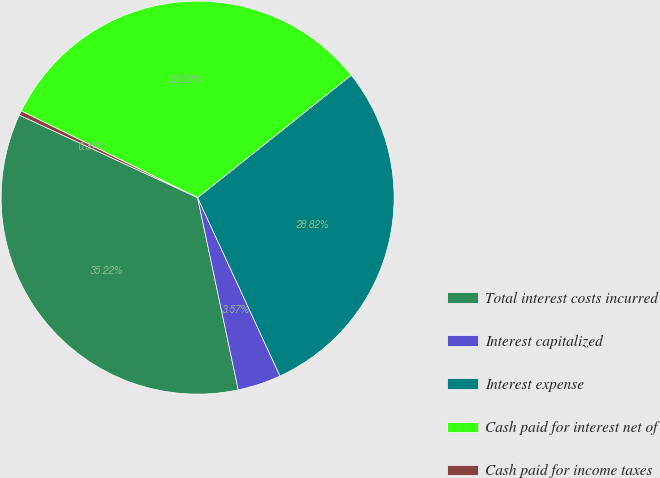Convert chart. <chart><loc_0><loc_0><loc_500><loc_500><pie_chart><fcel>Total interest costs incurred<fcel>Interest capitalized<fcel>Interest expense<fcel>Cash paid for interest net of<fcel>Cash paid for income taxes<nl><fcel>35.22%<fcel>3.57%<fcel>28.82%<fcel>32.02%<fcel>0.37%<nl></chart> 